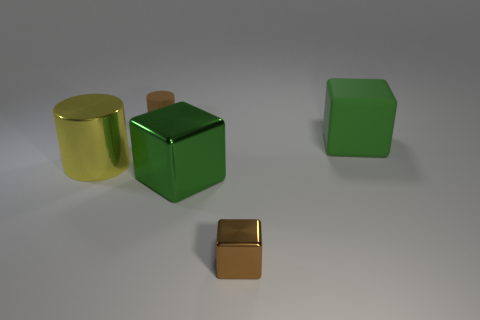Subtract all big green blocks. How many blocks are left? 1 Subtract all blue spheres. How many green cubes are left? 2 Subtract all brown cubes. How many cubes are left? 2 Add 2 large red metallic cylinders. How many objects exist? 7 Subtract all cubes. How many objects are left? 2 Subtract all purple blocks. Subtract all red cylinders. How many blocks are left? 3 Add 1 green shiny cubes. How many green shiny cubes are left? 2 Add 3 small cylinders. How many small cylinders exist? 4 Subtract 0 yellow spheres. How many objects are left? 5 Subtract all small yellow cylinders. Subtract all small brown objects. How many objects are left? 3 